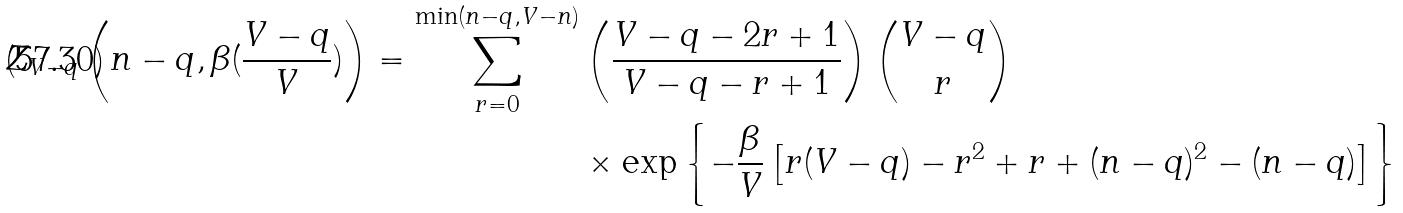Convert formula to latex. <formula><loc_0><loc_0><loc_500><loc_500>Z _ { V - q } \left ( n - q , \beta ( \frac { V - q } { V } ) \right ) = \sum _ { r = 0 } ^ { \min ( n - q , V - n ) } & \left ( \frac { V - q - 2 r + 1 } { V - q - r + 1 } \right ) \binom { V - q } { r } \\ & \times \exp \left \{ - \frac { \beta } { V } \left [ r ( V - q ) - r ^ { 2 } + r + ( n - q ) ^ { 2 } - ( n - q ) \right ] \right \}</formula> 